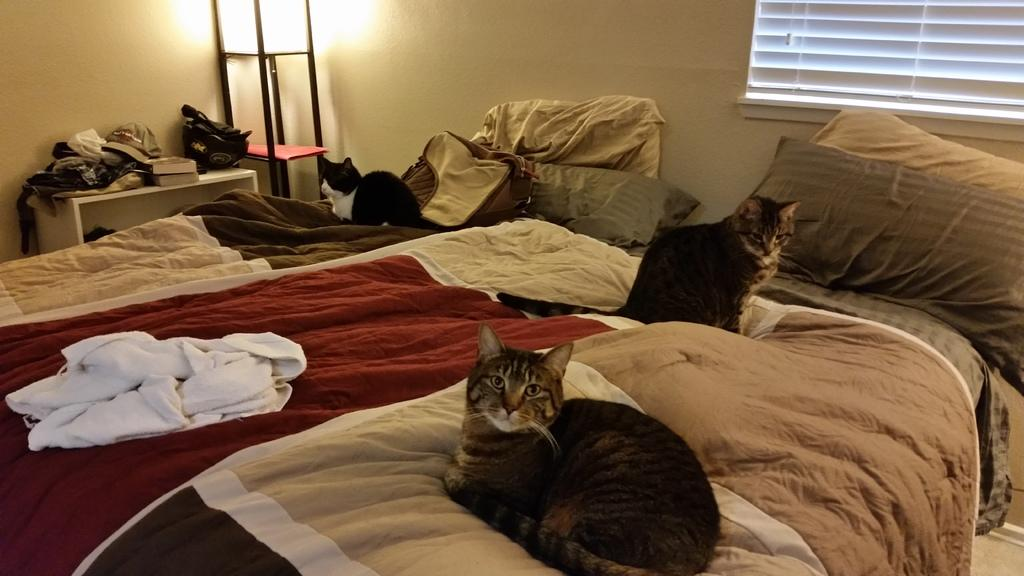How many cats are sitting on the bed in the image? There are 3 cats sitting on the bed. What is on the bed besides the cats? There is a white towel, a bag, and pillows on the bed. What is located at the left back of the image? There is a table at the left back of the image. What can be seen on the table? There are clothes on the table. What is present at the back of the image? There is a lamp at the back of the image. How does the image address the issue of pollution? The image does not address the issue of pollution, as it focuses on the cats, bed, and other items in the room. 